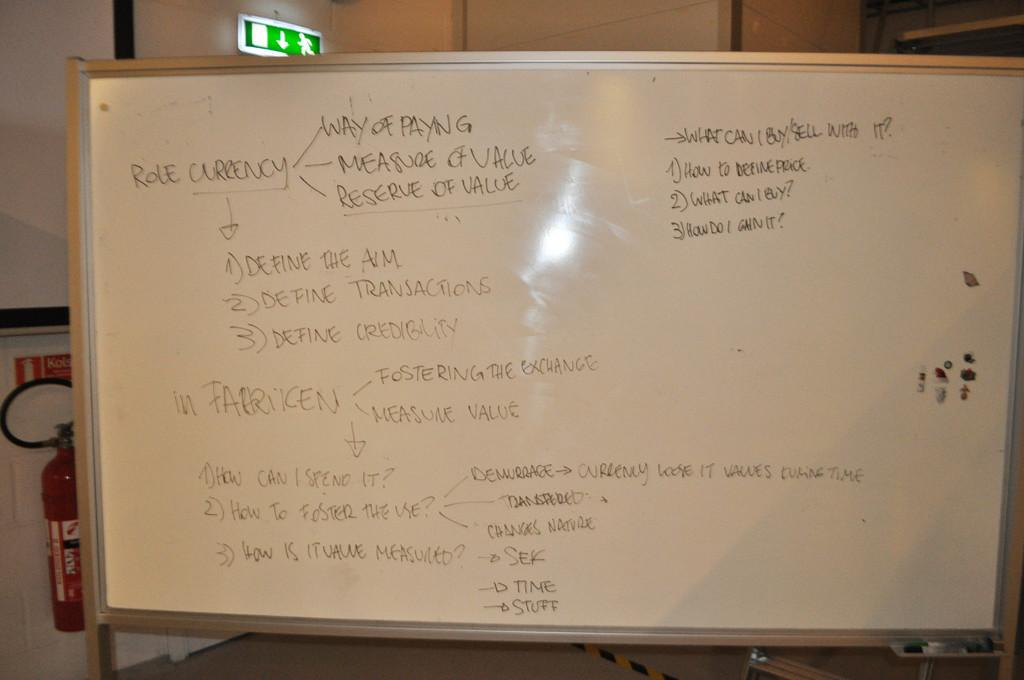<image>
Provide a brief description of the given image. "Role Currency" is written on a white board. 